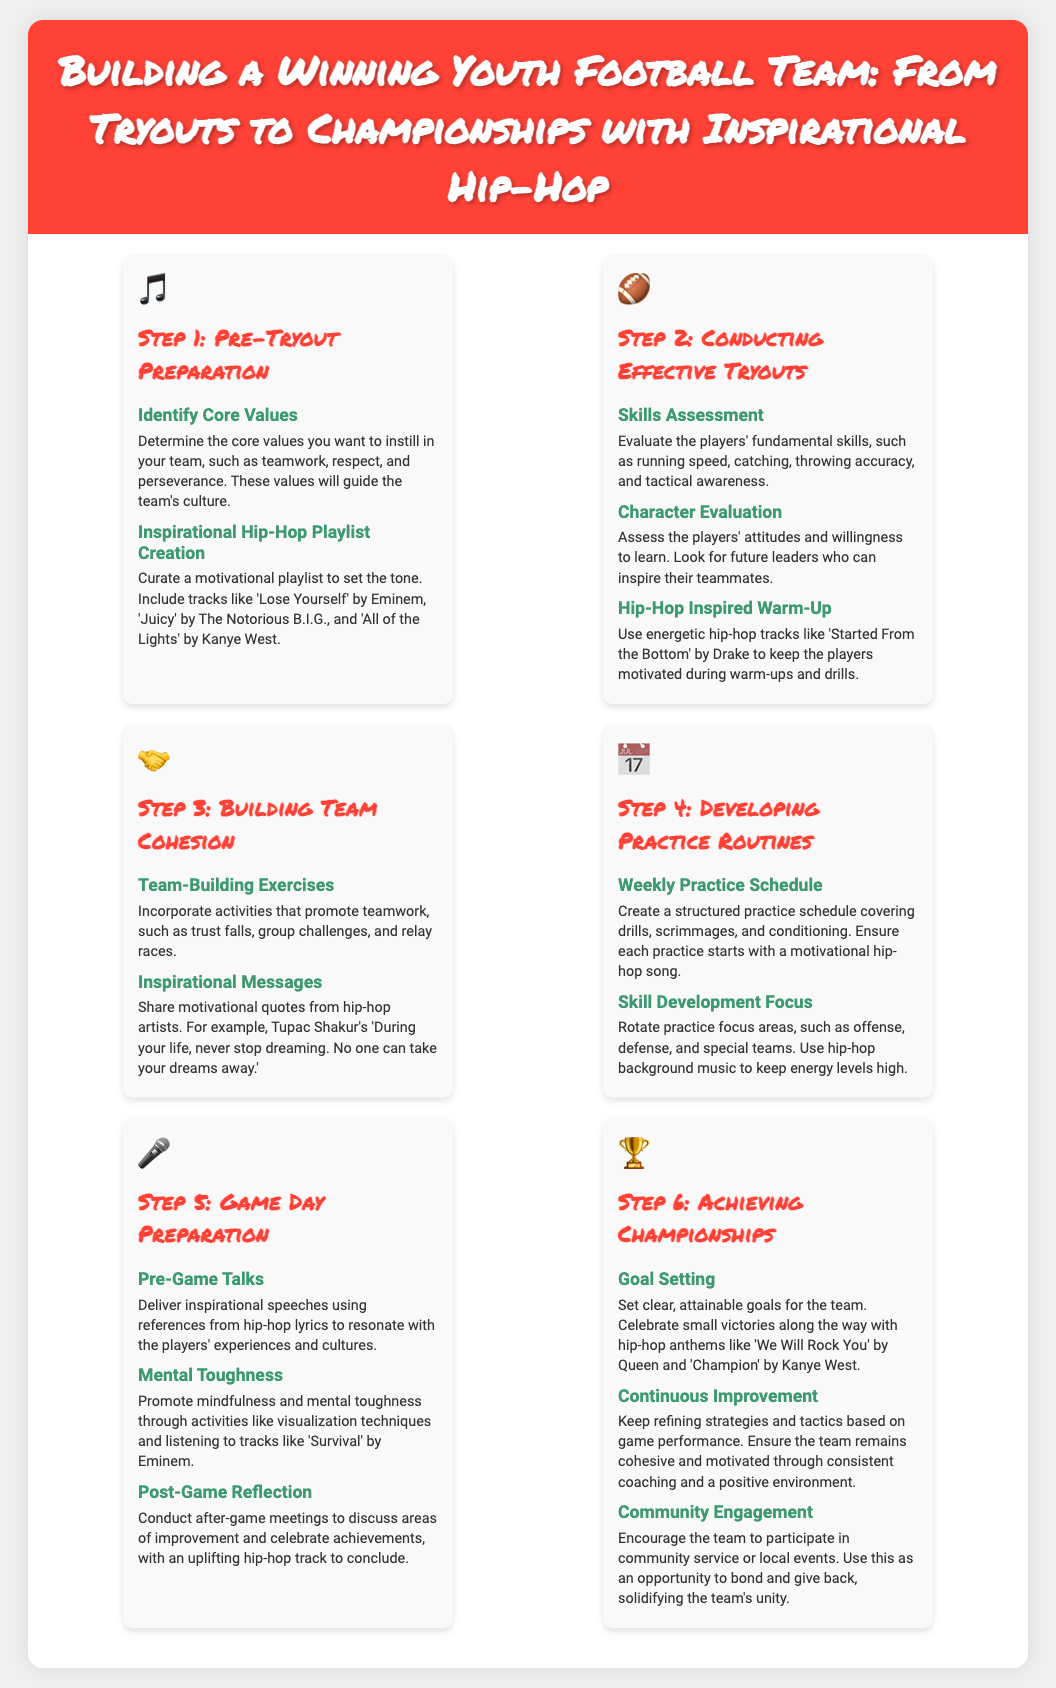What is the first step in building a winning youth football team? The first step outlined in the infographic is "Pre-Tryout Preparation."
Answer: Pre-Tryout Preparation Name one core value to instill in the team. The document mentions values such as teamwork, respect, and perseverance as core values.
Answer: Teamwork What must be assessed during effective tryouts? Skills such as running speed, catching, throwing accuracy, and tactical awareness need to be evaluated.
Answer: Skills Which hip-hop artist's song is recommended for pre-game talks? Eminem's lyrics and themes are suggested for inspirational speeches to resonate with players.
Answer: Eminem What should be included in the practice schedule? The practice schedule should cover drills, scrimmages, and conditioning.
Answer: Drills Which song is mentioned for promoting mental toughness? The infographic recommends listening to "Survival" by Eminem for mental toughness activities.
Answer: Survival What is one method to achieve championships according to the document? Setting clear, attainable goals for the team is crucial to achieving championships.
Answer: Goal Setting Name an activity to promote team cohesion. The infographic lists activities such as trust falls, group challenges, and relay races as team-building exercises.
Answer: Trust falls What type of music should be played during warm-ups? Energetic hip-hop tracks like "Started From the Bottom" by Drake should be used during warm-ups.
Answer: Started From the Bottom 